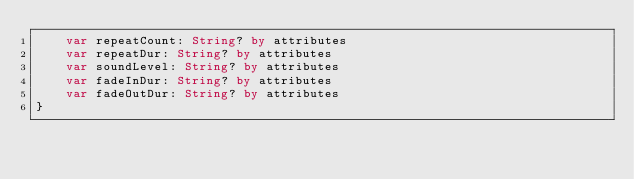<code> <loc_0><loc_0><loc_500><loc_500><_Kotlin_>    var repeatCount: String? by attributes
    var repeatDur: String? by attributes
    var soundLevel: String? by attributes
    var fadeInDur: String? by attributes
    var fadeOutDur: String? by attributes
}
</code> 